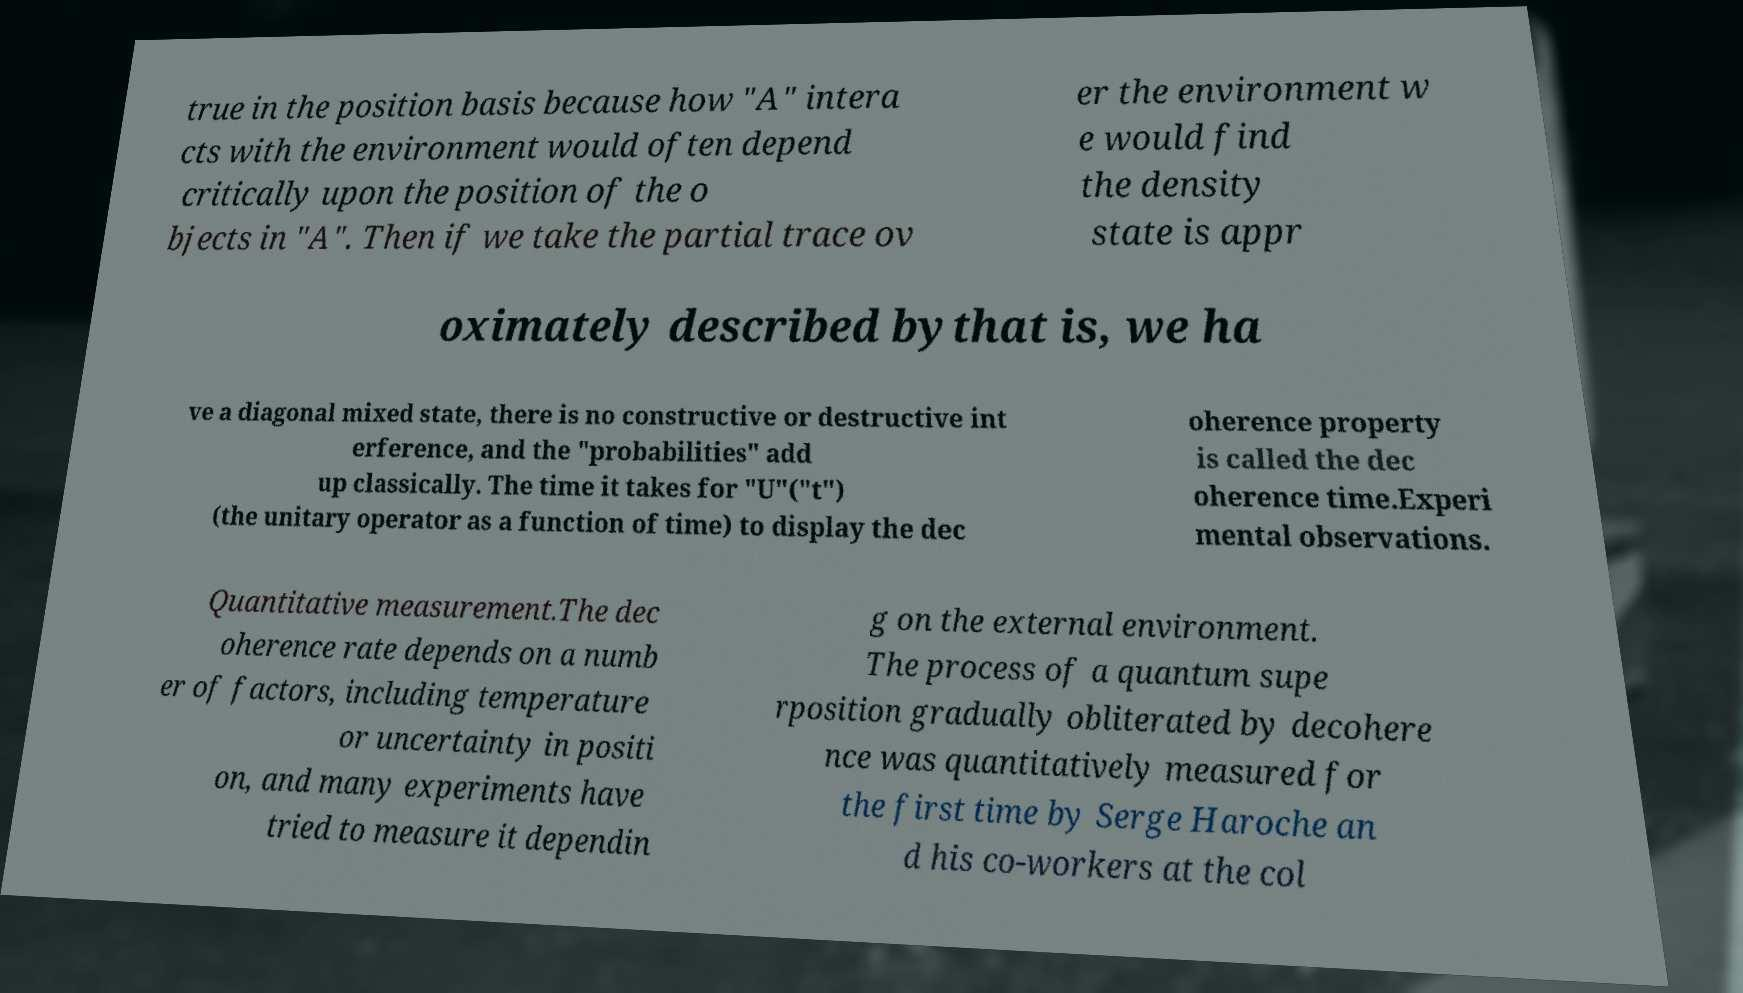What messages or text are displayed in this image? I need them in a readable, typed format. true in the position basis because how "A" intera cts with the environment would often depend critically upon the position of the o bjects in "A". Then if we take the partial trace ov er the environment w e would find the density state is appr oximately described bythat is, we ha ve a diagonal mixed state, there is no constructive or destructive int erference, and the "probabilities" add up classically. The time it takes for "U"("t") (the unitary operator as a function of time) to display the dec oherence property is called the dec oherence time.Experi mental observations. Quantitative measurement.The dec oherence rate depends on a numb er of factors, including temperature or uncertainty in positi on, and many experiments have tried to measure it dependin g on the external environment. The process of a quantum supe rposition gradually obliterated by decohere nce was quantitatively measured for the first time by Serge Haroche an d his co-workers at the col 